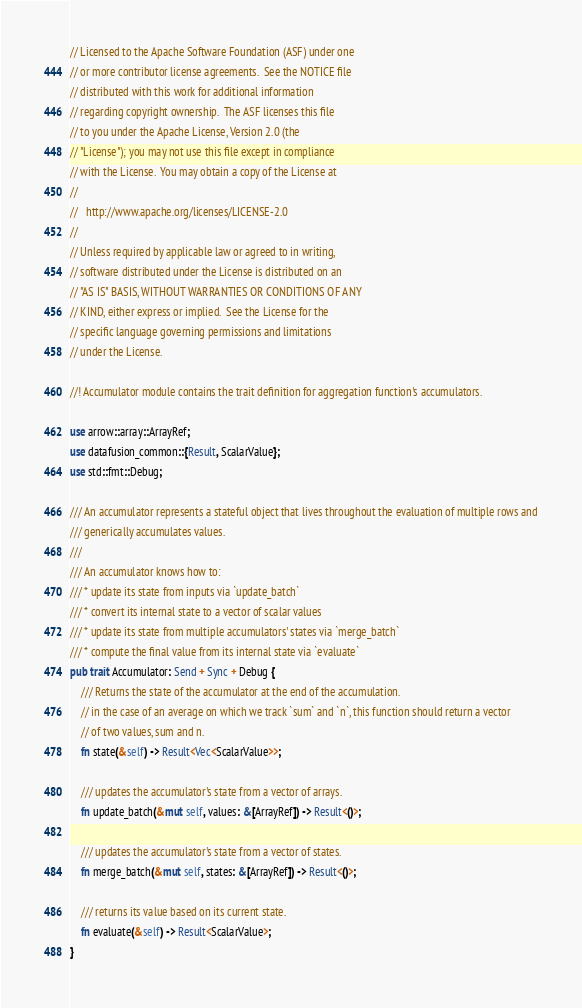<code> <loc_0><loc_0><loc_500><loc_500><_Rust_>// Licensed to the Apache Software Foundation (ASF) under one
// or more contributor license agreements.  See the NOTICE file
// distributed with this work for additional information
// regarding copyright ownership.  The ASF licenses this file
// to you under the Apache License, Version 2.0 (the
// "License"); you may not use this file except in compliance
// with the License.  You may obtain a copy of the License at
//
//   http://www.apache.org/licenses/LICENSE-2.0
//
// Unless required by applicable law or agreed to in writing,
// software distributed under the License is distributed on an
// "AS IS" BASIS, WITHOUT WARRANTIES OR CONDITIONS OF ANY
// KIND, either express or implied.  See the License for the
// specific language governing permissions and limitations
// under the License.

//! Accumulator module contains the trait definition for aggregation function's accumulators.

use arrow::array::ArrayRef;
use datafusion_common::{Result, ScalarValue};
use std::fmt::Debug;

/// An accumulator represents a stateful object that lives throughout the evaluation of multiple rows and
/// generically accumulates values.
///
/// An accumulator knows how to:
/// * update its state from inputs via `update_batch`
/// * convert its internal state to a vector of scalar values
/// * update its state from multiple accumulators' states via `merge_batch`
/// * compute the final value from its internal state via `evaluate`
pub trait Accumulator: Send + Sync + Debug {
    /// Returns the state of the accumulator at the end of the accumulation.
    // in the case of an average on which we track `sum` and `n`, this function should return a vector
    // of two values, sum and n.
    fn state(&self) -> Result<Vec<ScalarValue>>;

    /// updates the accumulator's state from a vector of arrays.
    fn update_batch(&mut self, values: &[ArrayRef]) -> Result<()>;

    /// updates the accumulator's state from a vector of states.
    fn merge_batch(&mut self, states: &[ArrayRef]) -> Result<()>;

    /// returns its value based on its current state.
    fn evaluate(&self) -> Result<ScalarValue>;
}
</code> 